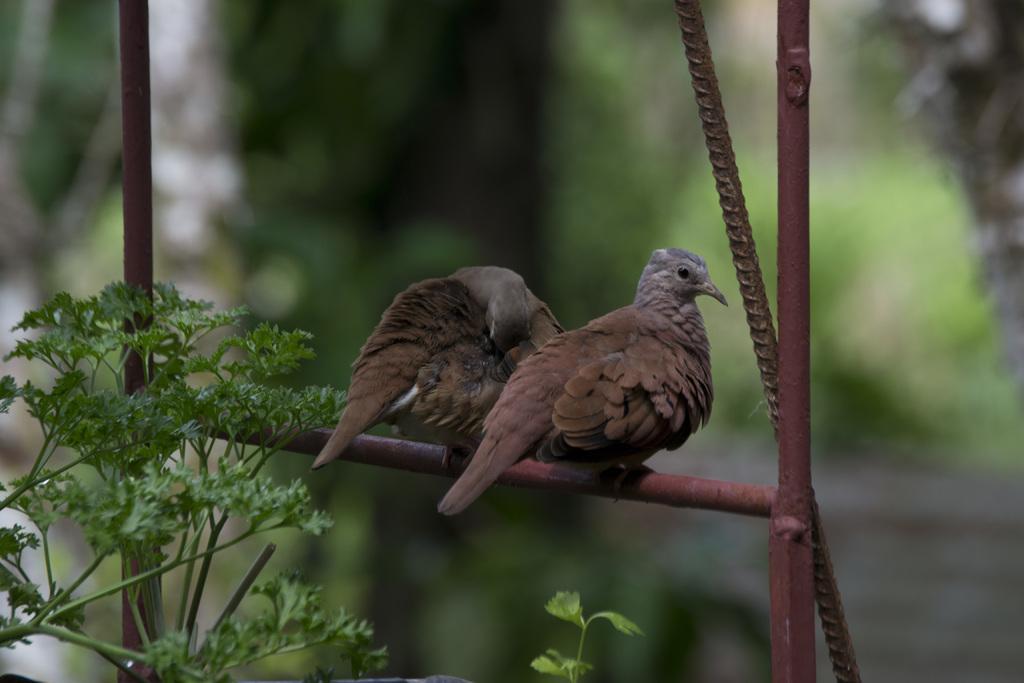Please provide a concise description of this image. In this picture, we see two birds on the iron rod. On the left side, we see the trees. In the background, it is green in color. This picture is blurred in the background. 